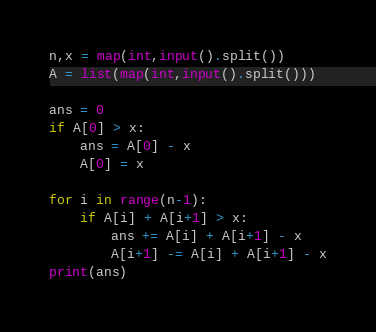<code> <loc_0><loc_0><loc_500><loc_500><_Python_>n,x = map(int,input().split())
A = list(map(int,input().split()))
 
ans = 0
if A[0] > x:
    ans = A[0] - x
    A[0] = x

for i in range(n-1):
    if A[i] + A[i+1] > x:
        ans += A[i] + A[i+1] - x
        A[i+1] -= A[i] + A[i+1] - x
print(ans)</code> 